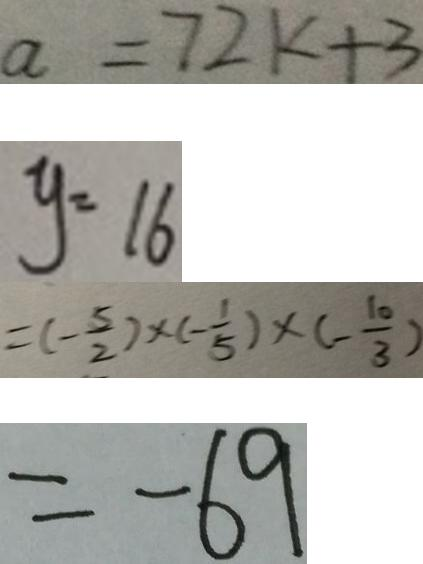Convert formula to latex. <formula><loc_0><loc_0><loc_500><loc_500>a = 7 2 k + 3 
 y = 1 6 
 = ( - \frac { 5 } { 2 } ) \times ( - \frac { 1 } { 5 } ) \times ( - \frac { 1 0 } { 3 } ) 
 = - 6 9</formula> 